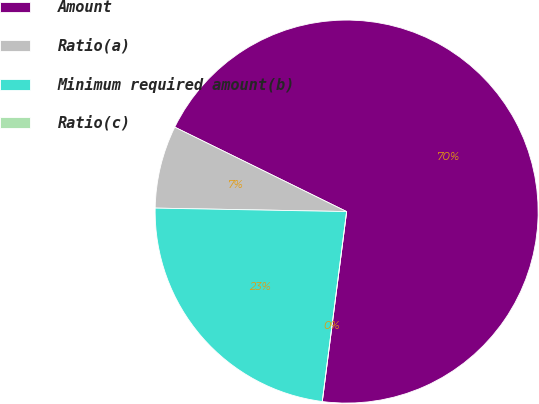Convert chart to OTSL. <chart><loc_0><loc_0><loc_500><loc_500><pie_chart><fcel>Amount<fcel>Ratio(a)<fcel>Minimum required amount(b)<fcel>Ratio(c)<nl><fcel>69.77%<fcel>6.98%<fcel>23.26%<fcel>0.0%<nl></chart> 